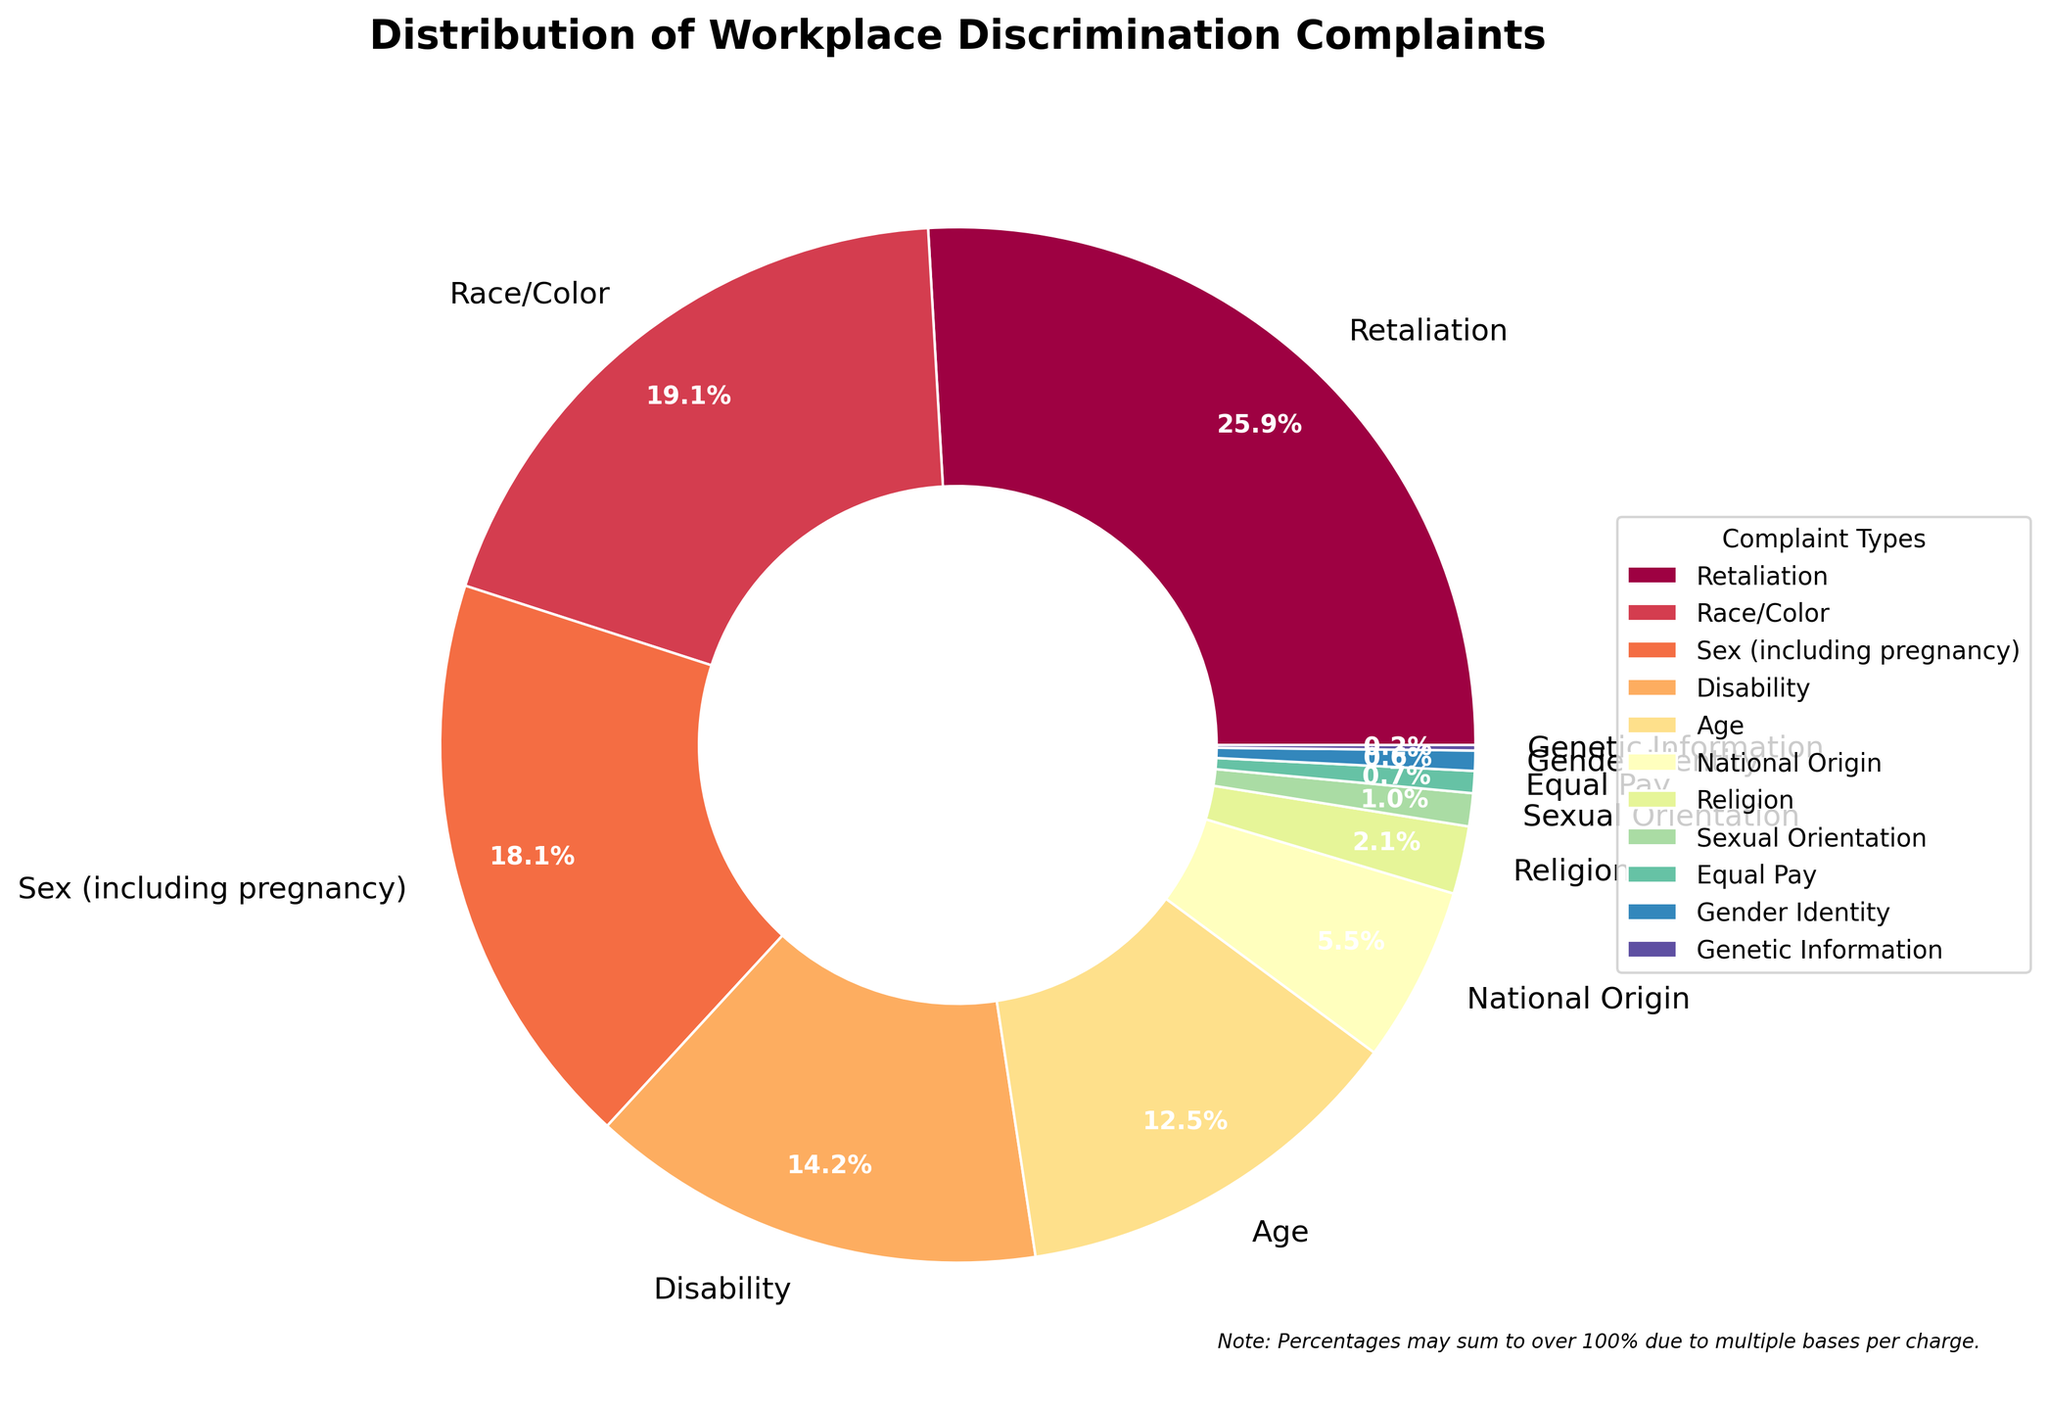Which type of workplace discrimination complaint has the highest percentage? The chart indicates that 'Retaliation' has the largest wedge in the pie chart, representing 45.3% of the complaints.
Answer: Retaliation What types of complaints collectively make up more than half of the total complaints? By adding the percentages of the largest categories: Retaliation (45.3%) and Race/Color (33.4%), the sum is 78.7%, which is more than half.
Answer: Retaliation, Race/Color What is the combined percentage of Sex (including pregnancy) and Disability complaints? The percentages for Sex (including pregnancy) and Disability are 31.7% and 24.9%, respectively. Adding these together, 31.7 + 24.9 = 56.6%.
Answer: 56.6% Which complaint type has the smallest percentage, and what is it? The smallest wedge in the pie chart represents Genetic Information, with a percentage of 0.3%.
Answer: Genetic Information, 0.3% How does the percentage of National Origin complaints compare to Religion complaints? According to the chart, National Origin complaints represent 9.6%, while Religion complaints account for 3.7%. National Origin has a higher percentage.
Answer: National Origin > Religion What is the combined percentage of the three lowest categories, and which are they? The three smallest categories are Genetic Information (0.3%), Equal Pay (1.2%), and Gender Identity (1.1%). Adding them together, 0.3 + 1.2 + 1.1 = 2.6%.
Answer: 2.6%; Genetic Information, Equal Pay, Gender Identity By how much does the percentage of Race/Color complaints exceed the percentage of Age complaints? The percentages are 33.4% for Race/Color and 21.8% for Age. The difference is 33.4 - 21.8 = 11.6%.
Answer: 11.6% Which complaint types are visually represented with the most and least prominent wedges in the chart, and what colors are they? The most prominent wedge is 'Retaliation' at 45.3%, and the least prominent is 'Genetic Information' at 0.3%. The color scheme is not specified, but they are visually distinguishable.
Answer: Most: Retaliation; Least: Genetic Information What is the difference between the combined percentage of Disability and Age complaints and the percentage of Retaliation complaints? Disability is 24.9% and Age is 21.8%, their combined percentage is 24.9 + 21.8 = 46.7%. Retaliation is 45.3%. Difference: 46.7 - 45.3 = 1.4%.
Answer: 1.4% 